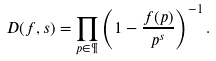Convert formula to latex. <formula><loc_0><loc_0><loc_500><loc_500>D ( f , s ) = \prod _ { p \in \P } \left ( 1 - \frac { f ( p ) } { p ^ { s } } \right ) ^ { - 1 } .</formula> 